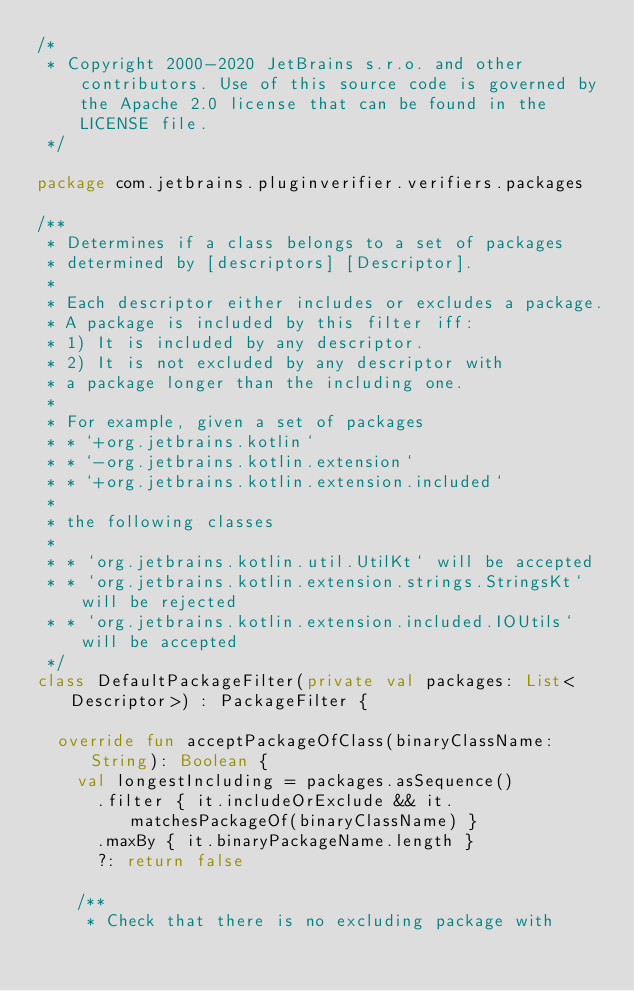<code> <loc_0><loc_0><loc_500><loc_500><_Kotlin_>/*
 * Copyright 2000-2020 JetBrains s.r.o. and other contributors. Use of this source code is governed by the Apache 2.0 license that can be found in the LICENSE file.
 */

package com.jetbrains.pluginverifier.verifiers.packages

/**
 * Determines if a class belongs to a set of packages
 * determined by [descriptors] [Descriptor].
 *
 * Each descriptor either includes or excludes a package.
 * A package is included by this filter iff:
 * 1) It is included by any descriptor.
 * 2) It is not excluded by any descriptor with
 * a package longer than the including one.
 *
 * For example, given a set of packages
 * * `+org.jetbrains.kotlin`
 * * `-org.jetbrains.kotlin.extension`
 * * `+org.jetbrains.kotlin.extension.included`
 *
 * the following classes
 *
 * * `org.jetbrains.kotlin.util.UtilKt` will be accepted
 * * `org.jetbrains.kotlin.extension.strings.StringsKt` will be rejected
 * * `org.jetbrains.kotlin.extension.included.IOUtils` will be accepted
 */
class DefaultPackageFilter(private val packages: List<Descriptor>) : PackageFilter {

  override fun acceptPackageOfClass(binaryClassName: String): Boolean {
    val longestIncluding = packages.asSequence()
      .filter { it.includeOrExclude && it.matchesPackageOf(binaryClassName) }
      .maxBy { it.binaryPackageName.length }
      ?: return false

    /**
     * Check that there is no excluding package with</code> 